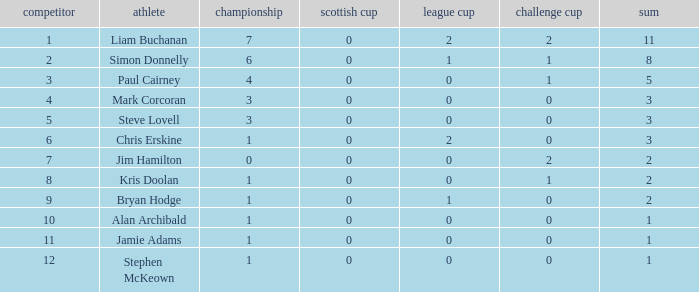How many points did player 7 score in the challenge cup? 1.0. 